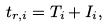Convert formula to latex. <formula><loc_0><loc_0><loc_500><loc_500>t _ { r , i } = T _ { i } + I _ { i } ,</formula> 